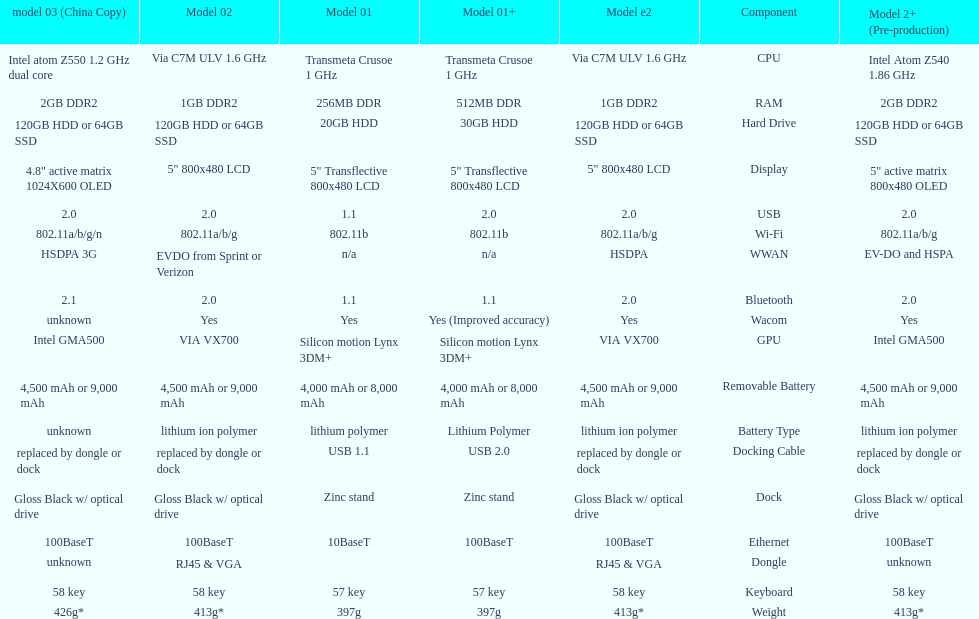How much more weight does the model 3 have over model 1? 29g. Write the full table. {'header': ['model 03 (China Copy)', 'Model 02', 'Model 01', 'Model 01+', 'Model e2', 'Component', 'Model 2+ (Pre-production)'], 'rows': [['Intel atom Z550 1.2\xa0GHz dual core', 'Via C7M ULV 1.6\xa0GHz', 'Transmeta Crusoe 1\xa0GHz', 'Transmeta Crusoe 1\xa0GHz', 'Via C7M ULV 1.6\xa0GHz', 'CPU', 'Intel Atom Z540 1.86\xa0GHz'], ['2GB DDR2', '1GB DDR2', '256MB DDR', '512MB DDR', '1GB DDR2', 'RAM', '2GB DDR2'], ['120GB HDD or 64GB SSD', '120GB HDD or 64GB SSD', '20GB HDD', '30GB HDD', '120GB HDD or 64GB SSD', 'Hard Drive', '120GB HDD or 64GB SSD'], ['4.8" active matrix 1024X600 OLED', '5" 800x480 LCD', '5" Transflective 800x480 LCD', '5" Transflective 800x480 LCD', '5" 800x480 LCD', 'Display', '5" active matrix 800x480 OLED'], ['2.0', '2.0', '1.1', '2.0', '2.0', 'USB', '2.0'], ['802.11a/b/g/n', '802.11a/b/g', '802.11b', '802.11b', '802.11a/b/g', 'Wi-Fi', '802.11a/b/g'], ['HSDPA 3G', 'EVDO from Sprint or Verizon', 'n/a', 'n/a', 'HSDPA', 'WWAN', 'EV-DO and HSPA'], ['2.1', '2.0', '1.1', '1.1', '2.0', 'Bluetooth', '2.0'], ['unknown', 'Yes', 'Yes', 'Yes (Improved accuracy)', 'Yes', 'Wacom', 'Yes'], ['Intel GMA500', 'VIA VX700', 'Silicon motion Lynx 3DM+', 'Silicon motion Lynx 3DM+', 'VIA VX700', 'GPU', 'Intel GMA500'], ['4,500 mAh or 9,000 mAh', '4,500 mAh or 9,000 mAh', '4,000 mAh or 8,000 mAh', '4,000 mAh or 8,000 mAh', '4,500 mAh or 9,000 mAh', 'Removable Battery', '4,500 mAh or 9,000 mAh'], ['unknown', 'lithium ion polymer', 'lithium polymer', 'Lithium Polymer', 'lithium ion polymer', 'Battery Type', 'lithium ion polymer'], ['replaced by dongle or dock', 'replaced by dongle or dock', 'USB 1.1', 'USB 2.0', 'replaced by dongle or dock', 'Docking Cable', 'replaced by dongle or dock'], ['Gloss Black w/ optical drive', 'Gloss Black w/ optical drive', 'Zinc stand', 'Zinc stand', 'Gloss Black w/ optical drive', 'Dock', 'Gloss Black w/ optical drive'], ['100BaseT', '100BaseT', '10BaseT', '100BaseT', '100BaseT', 'Ethernet', '100BaseT'], ['unknown', 'RJ45 & VGA', '', '', 'RJ45 & VGA', 'Dongle', 'unknown'], ['58 key', '58 key', '57 key', '57 key', '58 key', 'Keyboard', '58 key'], ['426g*', '413g*', '397g', '397g', '413g*', 'Weight', '413g*']]} 